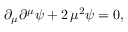Convert formula to latex. <formula><loc_0><loc_0><loc_500><loc_500>\partial _ { \mu } \partial ^ { \mu } \psi + 2 \, \mu ^ { 2 } \psi = 0 ,</formula> 